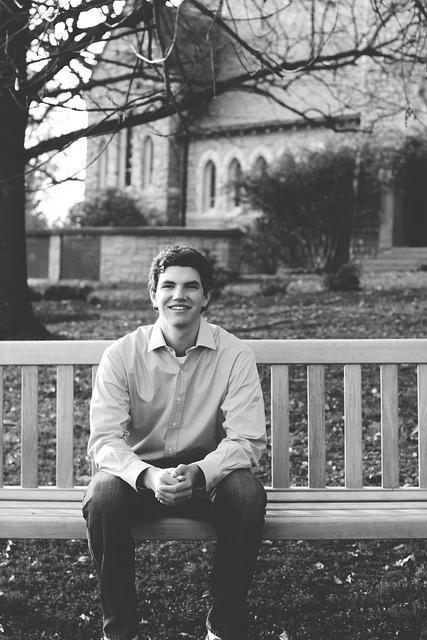How many horses are here?
Give a very brief answer. 0. 